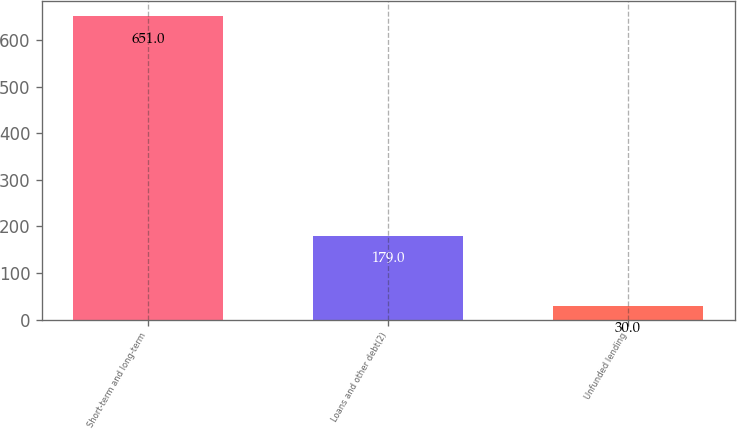Convert chart. <chart><loc_0><loc_0><loc_500><loc_500><bar_chart><fcel>Short-term and long-term<fcel>Loans and other debt(2)<fcel>Unfunded lending<nl><fcel>651<fcel>179<fcel>30<nl></chart> 